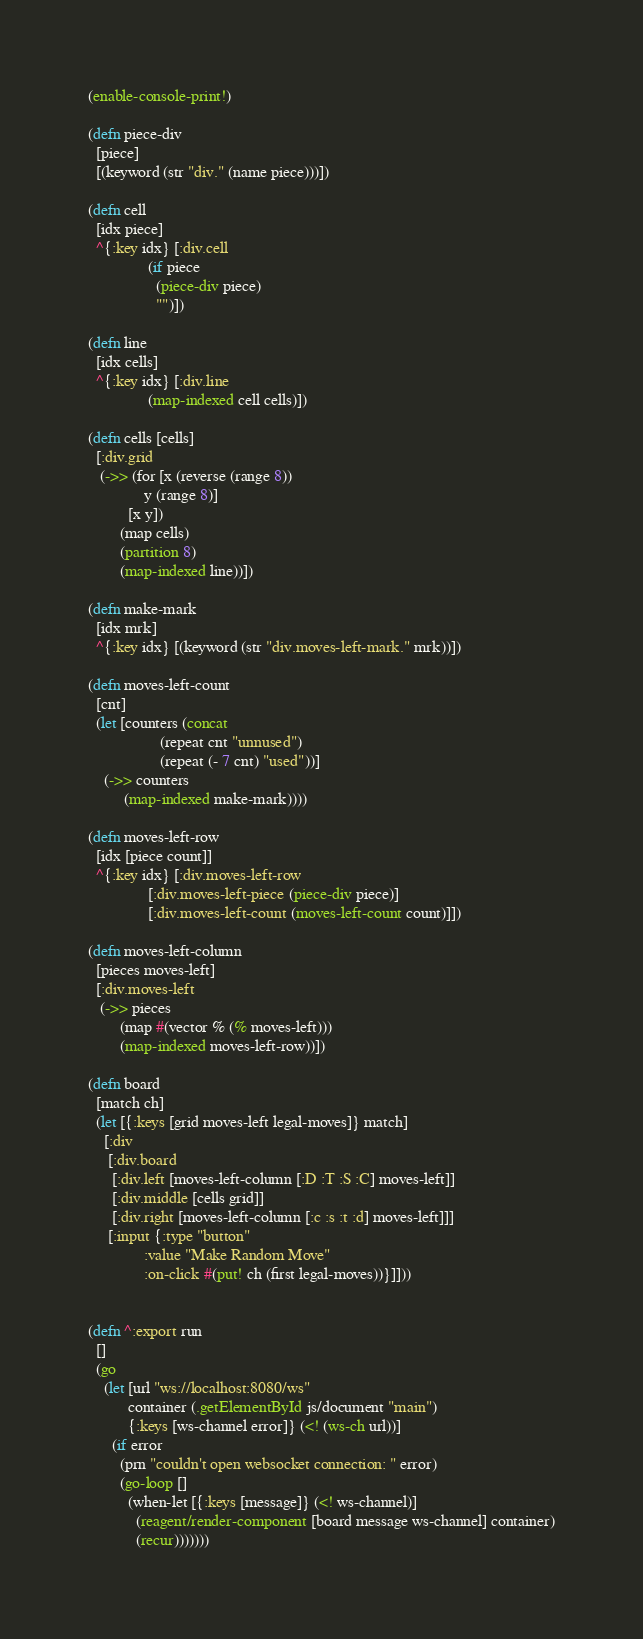<code> <loc_0><loc_0><loc_500><loc_500><_Clojure_>
(enable-console-print!)

(defn piece-div
  [piece]
  [(keyword (str "div." (name piece)))])

(defn cell
  [idx piece]
  ^{:key idx} [:div.cell
               (if piece
                 (piece-div piece)
                 "")])

(defn line
  [idx cells]
  ^{:key idx} [:div.line
               (map-indexed cell cells)])

(defn cells [cells]
  [:div.grid
   (->> (for [x (reverse (range 8))
              y (range 8)]
          [x y])
        (map cells)
        (partition 8)
        (map-indexed line))])

(defn make-mark
  [idx mrk]
  ^{:key idx} [(keyword (str "div.moves-left-mark." mrk))])

(defn moves-left-count
  [cnt]
  (let [counters (concat
                  (repeat cnt "unnused")
                  (repeat (- 7 cnt) "used"))]
    (->> counters
         (map-indexed make-mark))))

(defn moves-left-row
  [idx [piece count]]
  ^{:key idx} [:div.moves-left-row
               [:div.moves-left-piece (piece-div piece)]
               [:div.moves-left-count (moves-left-count count)]])

(defn moves-left-column
  [pieces moves-left]
  [:div.moves-left
   (->> pieces
        (map #(vector % (% moves-left)))
        (map-indexed moves-left-row))])

(defn board
  [match ch]
  (let [{:keys [grid moves-left legal-moves]} match]
    [:div
     [:div.board
      [:div.left [moves-left-column [:D :T :S :C] moves-left]]
      [:div.middle [cells grid]]
      [:div.right [moves-left-column [:c :s :t :d] moves-left]]]
     [:input {:type "button"
              :value "Make Random Move"
              :on-click #(put! ch (first legal-moves))}]]))


(defn ^:export run
  []
  (go
    (let [url "ws://localhost:8080/ws"
          container (.getElementById js/document "main")
          {:keys [ws-channel error]} (<! (ws-ch url))]
      (if error
        (prn "couldn't open websocket connection: " error)
        (go-loop []
          (when-let [{:keys [message]} (<! ws-channel)]
            (reagent/render-component [board message ws-channel] container)
            (recur)))))))
</code> 